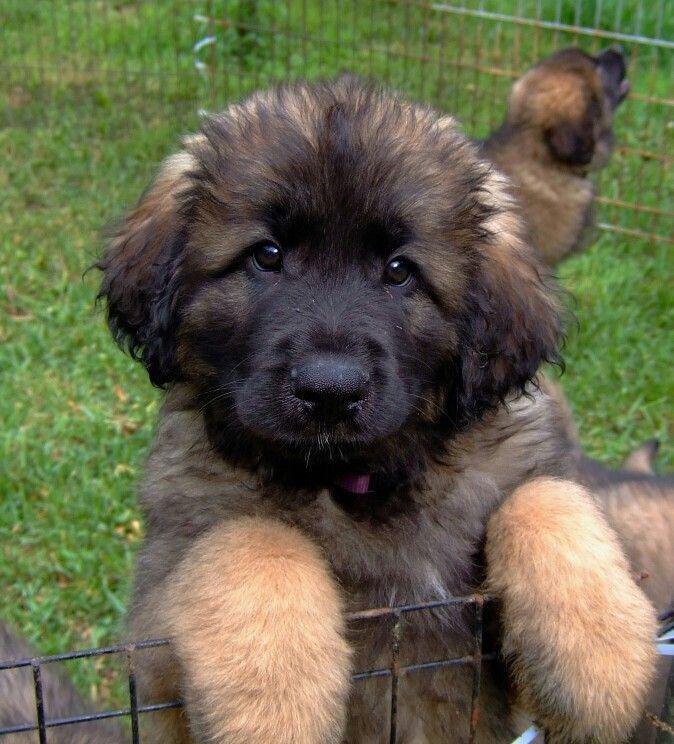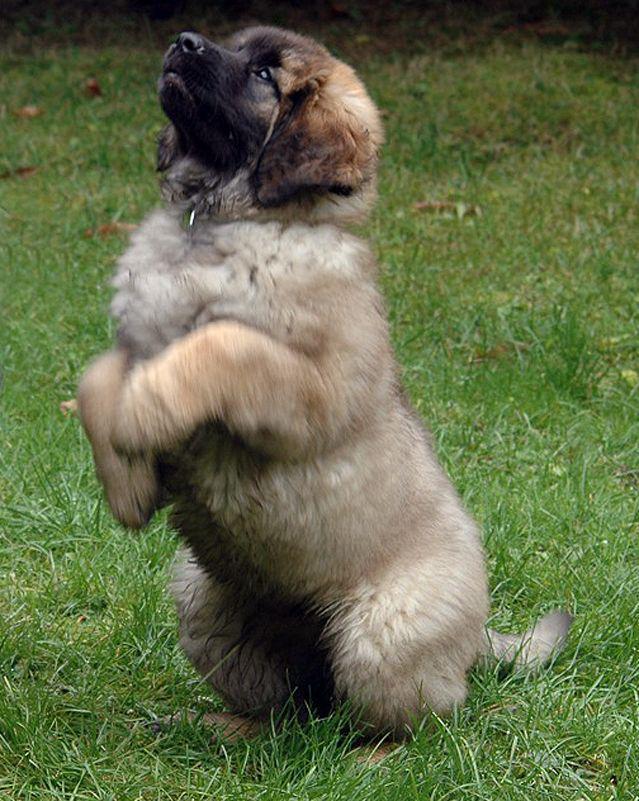The first image is the image on the left, the second image is the image on the right. Given the left and right images, does the statement "There are no more than three dogs" hold true? Answer yes or no. Yes. 